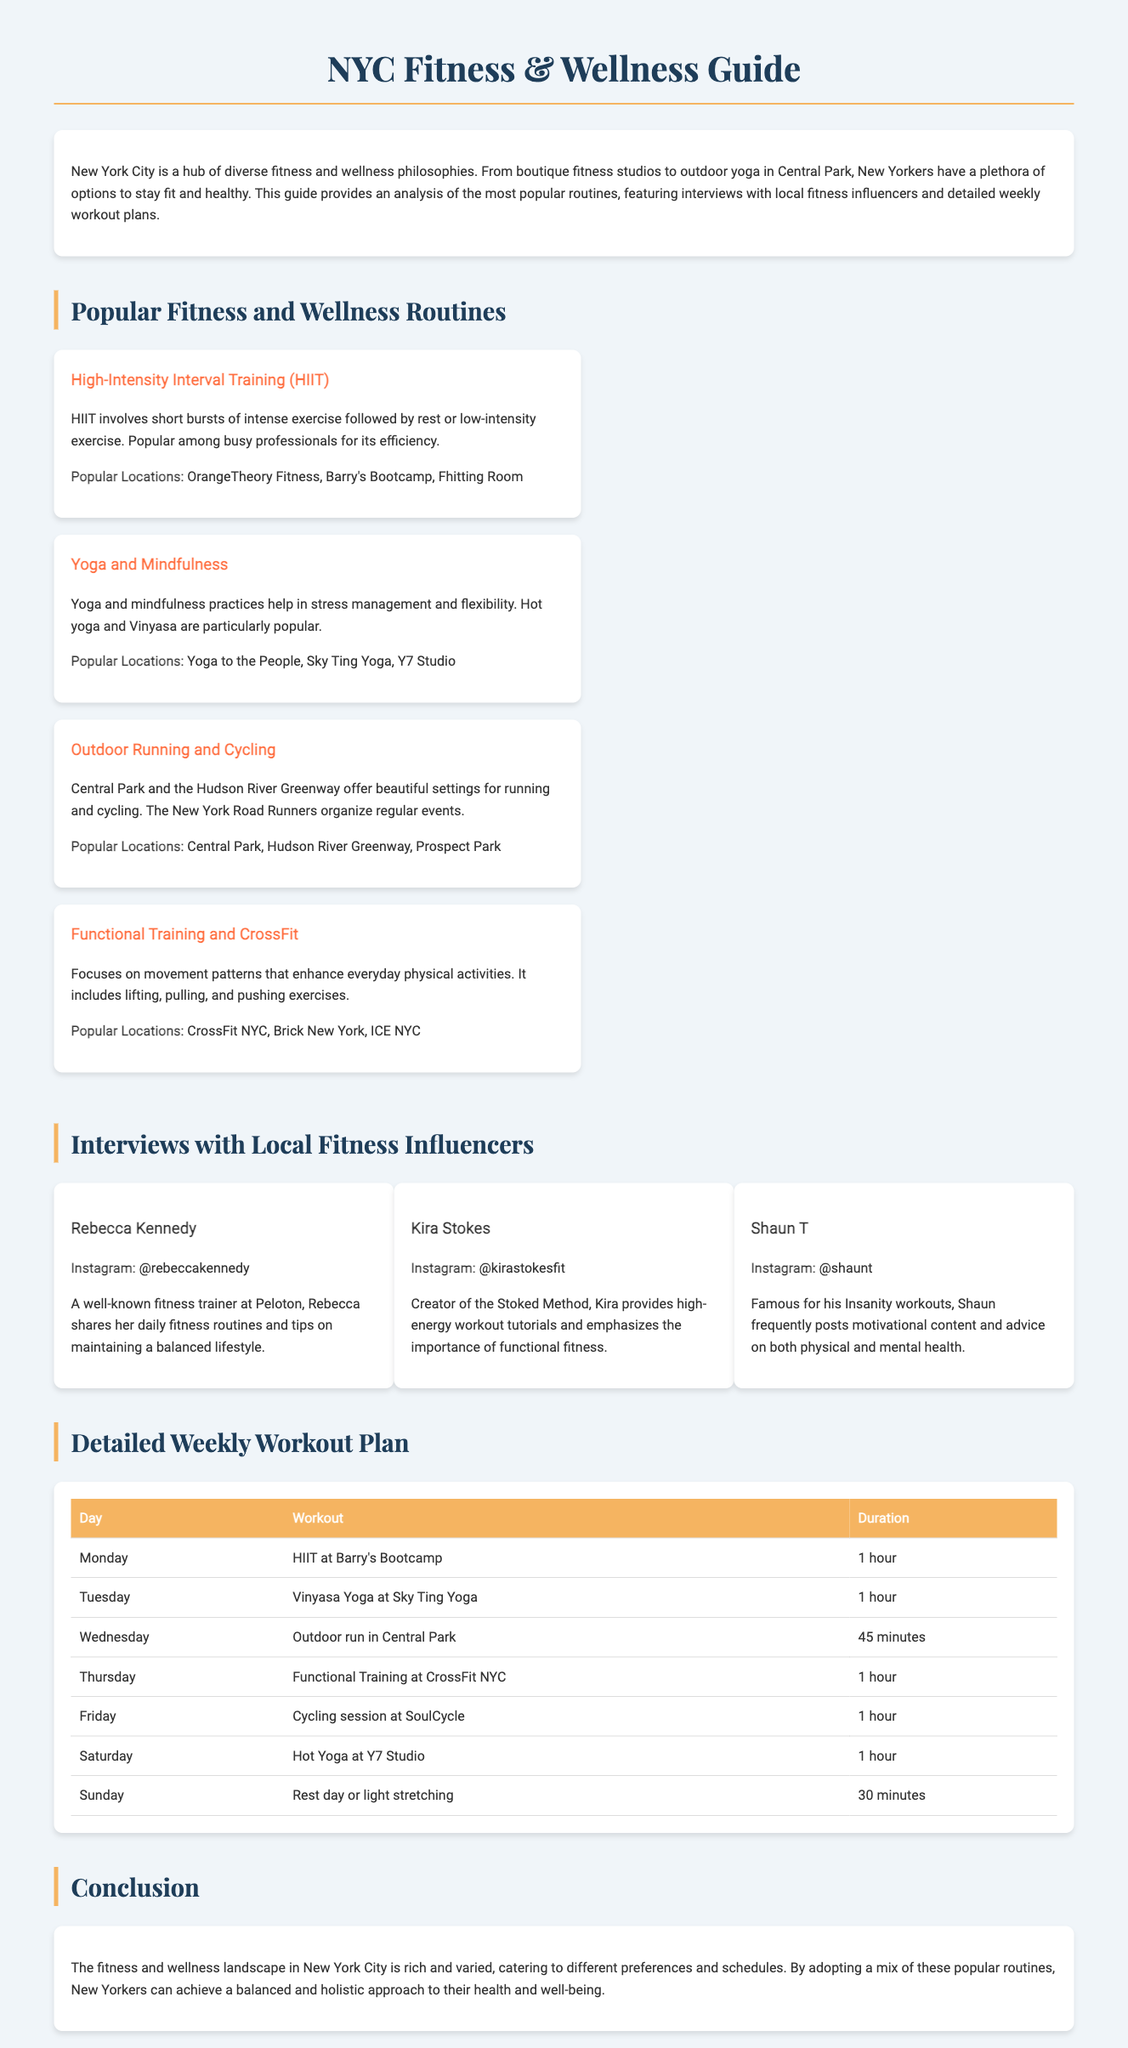What is the title of the guide? The title of the guide is provided in the HTML document's title tag, which is "NYC Fitness & Wellness Guide."
Answer: NYC Fitness & Wellness Guide What is one popular fitness routine mentioned? The document lists several popular routines, one of which is "High-Intensity Interval Training (HIIT)."
Answer: High-Intensity Interval Training (HIIT) Who is one fitness influencer interviewed? The document features interviews with fitness influencers, one of whom is "Rebecca Kennedy."
Answer: Rebecca Kennedy How long is the HIIT workout at Barry's Bootcamp? The schedule in the document states that the HIIT workout at Barry's Bootcamp lasts for 1 hour.
Answer: 1 hour What day is designated as a rest day? According to the weekly workout plan in the document, Sunday is designated as a rest day.
Answer: Sunday What type of yoga is particularly popular? The document mentions "Hot yoga and Vinyasa" as particularly popular types of yoga.
Answer: Hot yoga and Vinyasa Which location is popular for outdoor running? The document lists "Central Park" as a popular location for outdoor running.
Answer: Central Park What is the workout for Friday? The weekly workout plan specifies that the workout for Friday is "Cycling session at SoulCycle."
Answer: Cycling session at SoulCycle Which fitness influencer created the Stoked Method? The document states that "Kira Stokes" is the creator of the Stoked Method.
Answer: Kira Stokes 